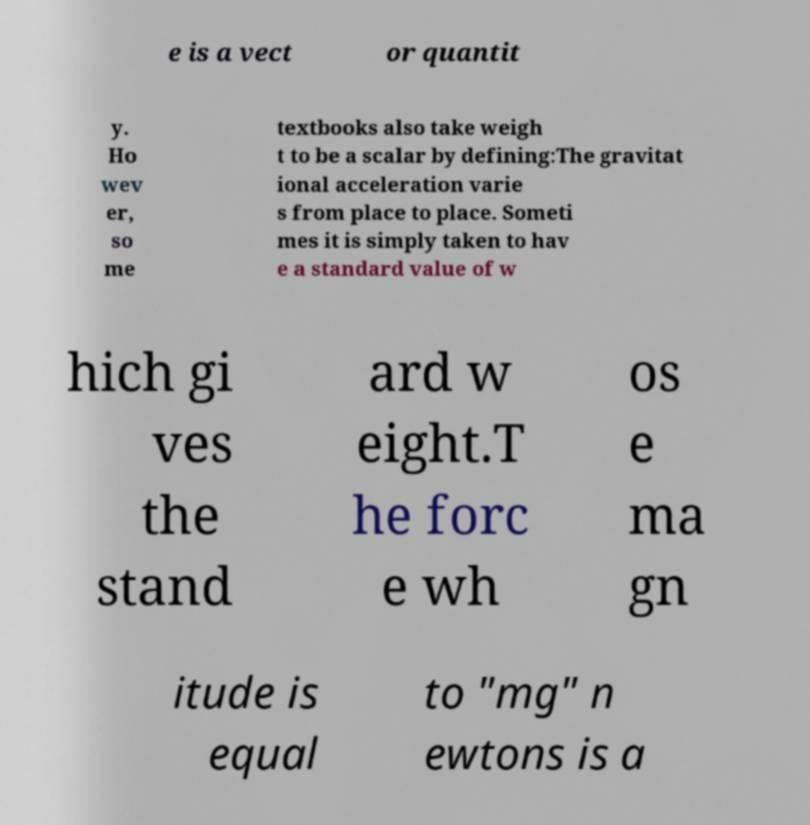Please read and relay the text visible in this image. What does it say? e is a vect or quantit y. Ho wev er, so me textbooks also take weigh t to be a scalar by defining:The gravitat ional acceleration varie s from place to place. Someti mes it is simply taken to hav e a standard value of w hich gi ves the stand ard w eight.T he forc e wh os e ma gn itude is equal to "mg" n ewtons is a 